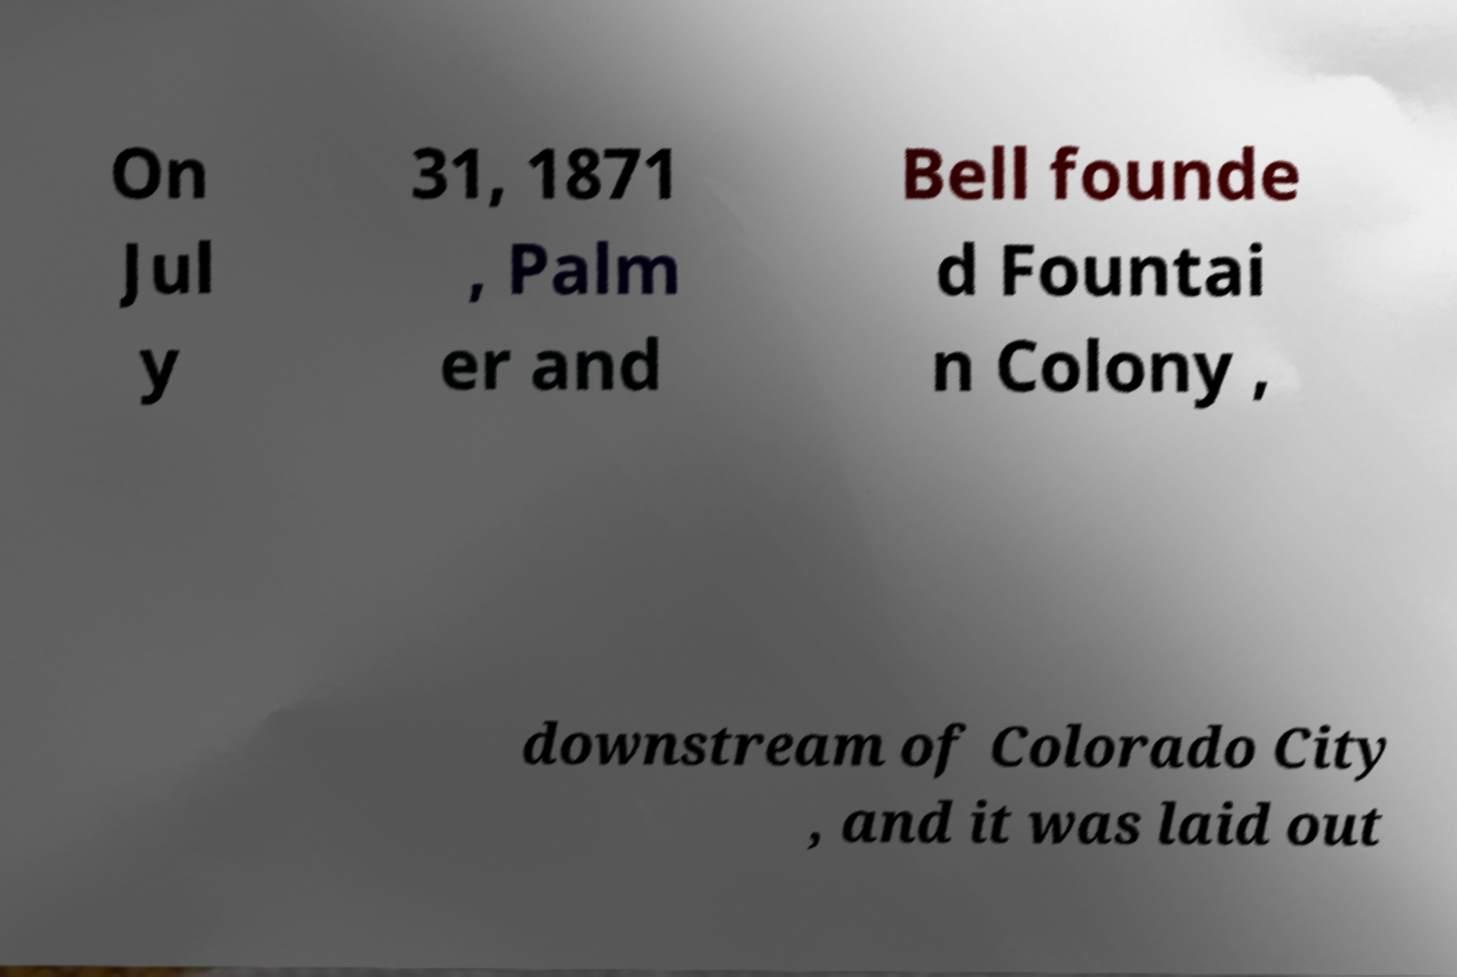What messages or text are displayed in this image? I need them in a readable, typed format. On Jul y 31, 1871 , Palm er and Bell founde d Fountai n Colony , downstream of Colorado City , and it was laid out 